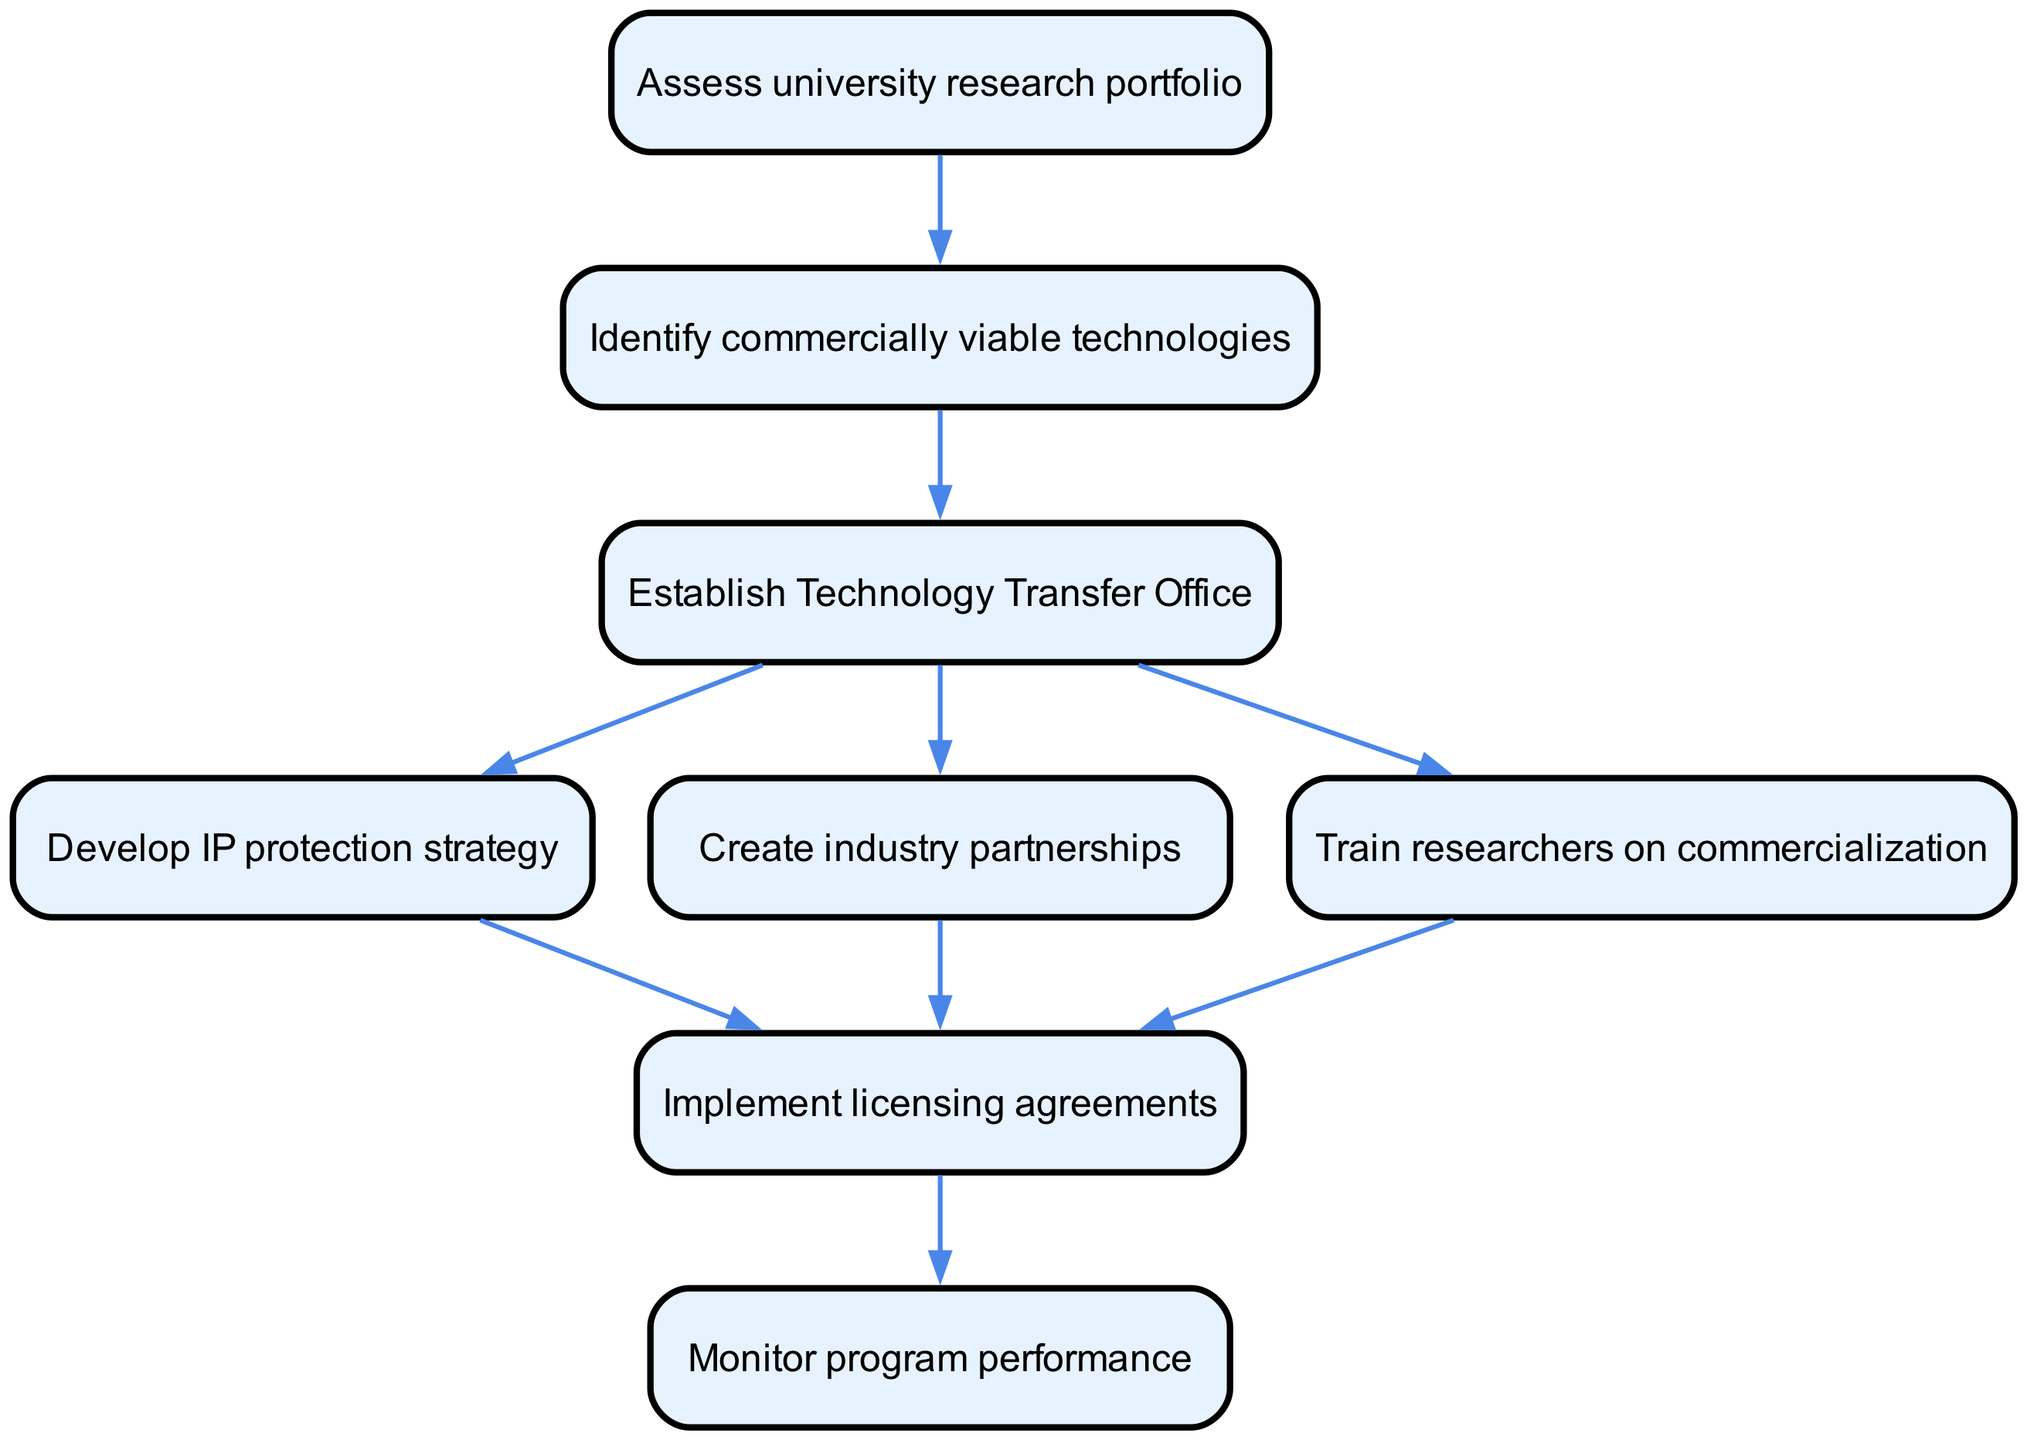What is the first step in the diagram? The first node in the flowchart is labeled "Assess university research portfolio", indicating that this is the initial action required in the technology transfer program.
Answer: Assess university research portfolio How many nodes are present in the flowchart? By counting each labeled node in the diagram, there are a total of 8 nodes representing different steps in the process.
Answer: 8 What is the last step in the flowchart? The final node in the flowchart is "Monitor program performance", which signifies the conclusion of the process.
Answer: Monitor program performance Which node follows "Identify commercially viable technologies"? The edge from the node "Identify commercially viable technologies" points to "Establish Technology Transfer Office", indicating this is the next step in the flowchart.
Answer: Establish Technology Transfer Office What nodes are connected to the "Establish Technology Transfer Office" node? The "Establish Technology Transfer Office" node has three outgoing edges leading to the nodes "Develop IP protection strategy", "Create industry partnerships", and "Train researchers on commercialization", showing its connections.
Answer: Develop IP protection strategy, Create industry partnerships, Train researchers on commercialization How does the flowchart indicate the relationship between "Develop IP protection strategy" and "Implement licensing agreements"? The arrow from "Develop IP protection strategy" to "Implement licensing agreements" signifies that completing the IP protection strategy is a prerequisite for moving to licensing agreements.
Answer: Implement licensing agreements How many edges are in the flowchart? By counting each connection between the nodes in the diagram, there are a total of 9 edges that represent the flow of the process.
Answer: 9 Which step is necessary before monitoring program performance? The node "Implement licensing agreements" must be completed prior to "Monitor program performance", as indicated by the edge connecting them.
Answer: Implement licensing agreements 